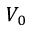<formula> <loc_0><loc_0><loc_500><loc_500>V _ { 0 }</formula> 